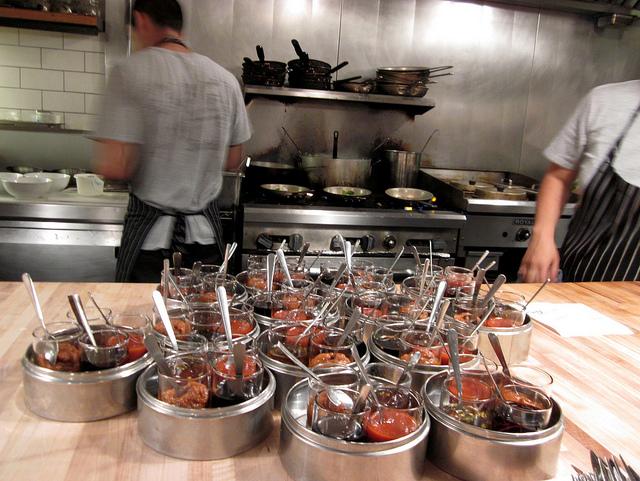How cooks are there?
Short answer required. 2. How many spoons are there?
Short answer required. 56. What is there a lot of on the table?
Answer briefly. Containers. 